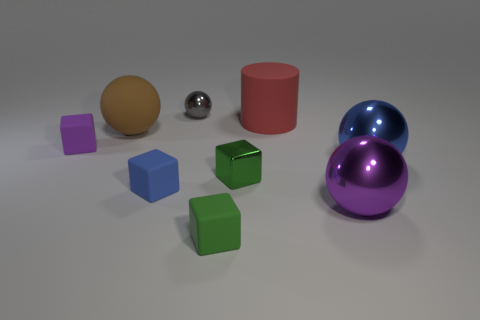How many other cubes have the same color as the tiny shiny block?
Give a very brief answer. 1. Do the tiny green object in front of the metallic cube and the purple object that is behind the big blue metal sphere have the same shape?
Ensure brevity in your answer.  Yes. How many other things are there of the same color as the metallic cube?
Provide a short and direct response. 1. Are the ball that is to the right of the purple metal thing and the object that is to the left of the brown sphere made of the same material?
Your answer should be compact. No. Are there an equal number of tiny purple rubber cubes to the right of the gray metallic sphere and tiny blue rubber cubes that are right of the red matte cylinder?
Provide a short and direct response. Yes. There is a big thing that is to the left of the large red thing; what is it made of?
Your response must be concise. Rubber. Is the number of small gray shiny spheres less than the number of green objects?
Keep it short and to the point. Yes. There is a large thing that is behind the large blue sphere and in front of the big matte cylinder; what is its shape?
Ensure brevity in your answer.  Sphere. What number of shiny objects are there?
Your answer should be very brief. 4. What material is the big sphere that is to the left of the blue thing that is to the left of the metal thing that is left of the green matte object made of?
Keep it short and to the point. Rubber. 